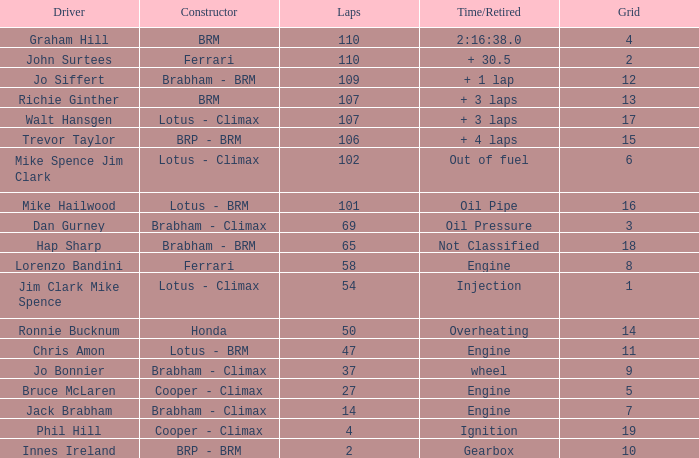What time/retired for grid 18? Not Classified. 